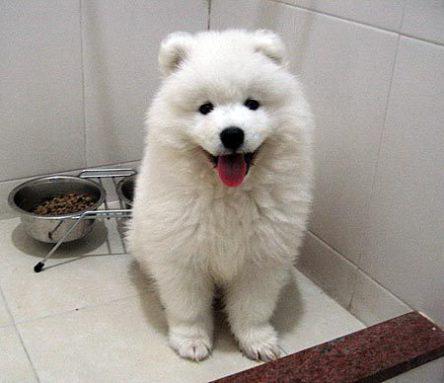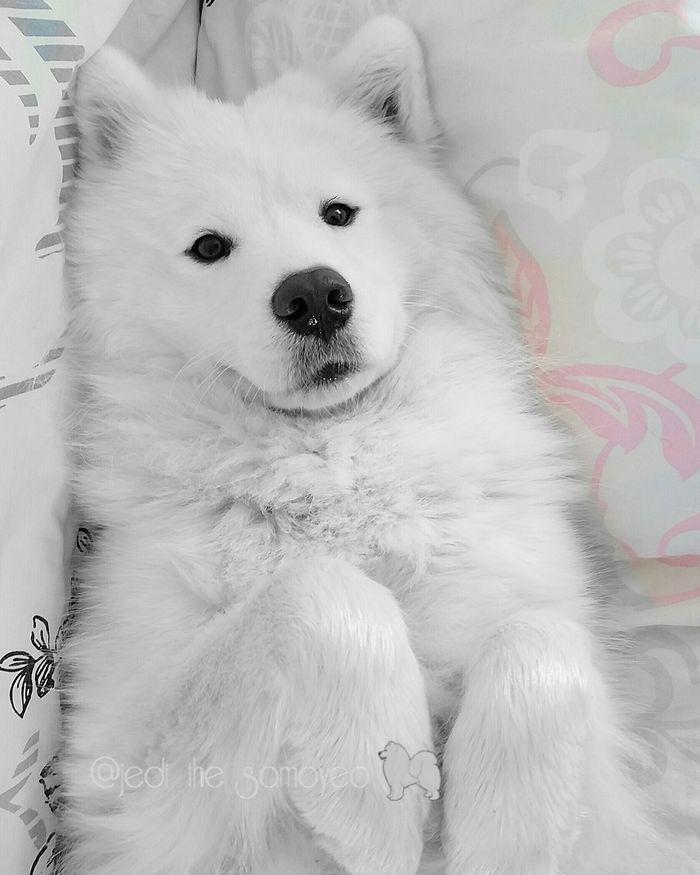The first image is the image on the left, the second image is the image on the right. Considering the images on both sides, is "At least one of the dogs is standing outside." valid? Answer yes or no. No. The first image is the image on the left, the second image is the image on the right. For the images shown, is this caption "Right image features a white dog with its mouth open and tongue showing." true? Answer yes or no. No. The first image is the image on the left, the second image is the image on the right. Analyze the images presented: Is the assertion "An image shows a white dog posed indoors in a white room." valid? Answer yes or no. Yes. 